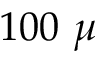Convert formula to latex. <formula><loc_0><loc_0><loc_500><loc_500>1 0 0 \mu</formula> 